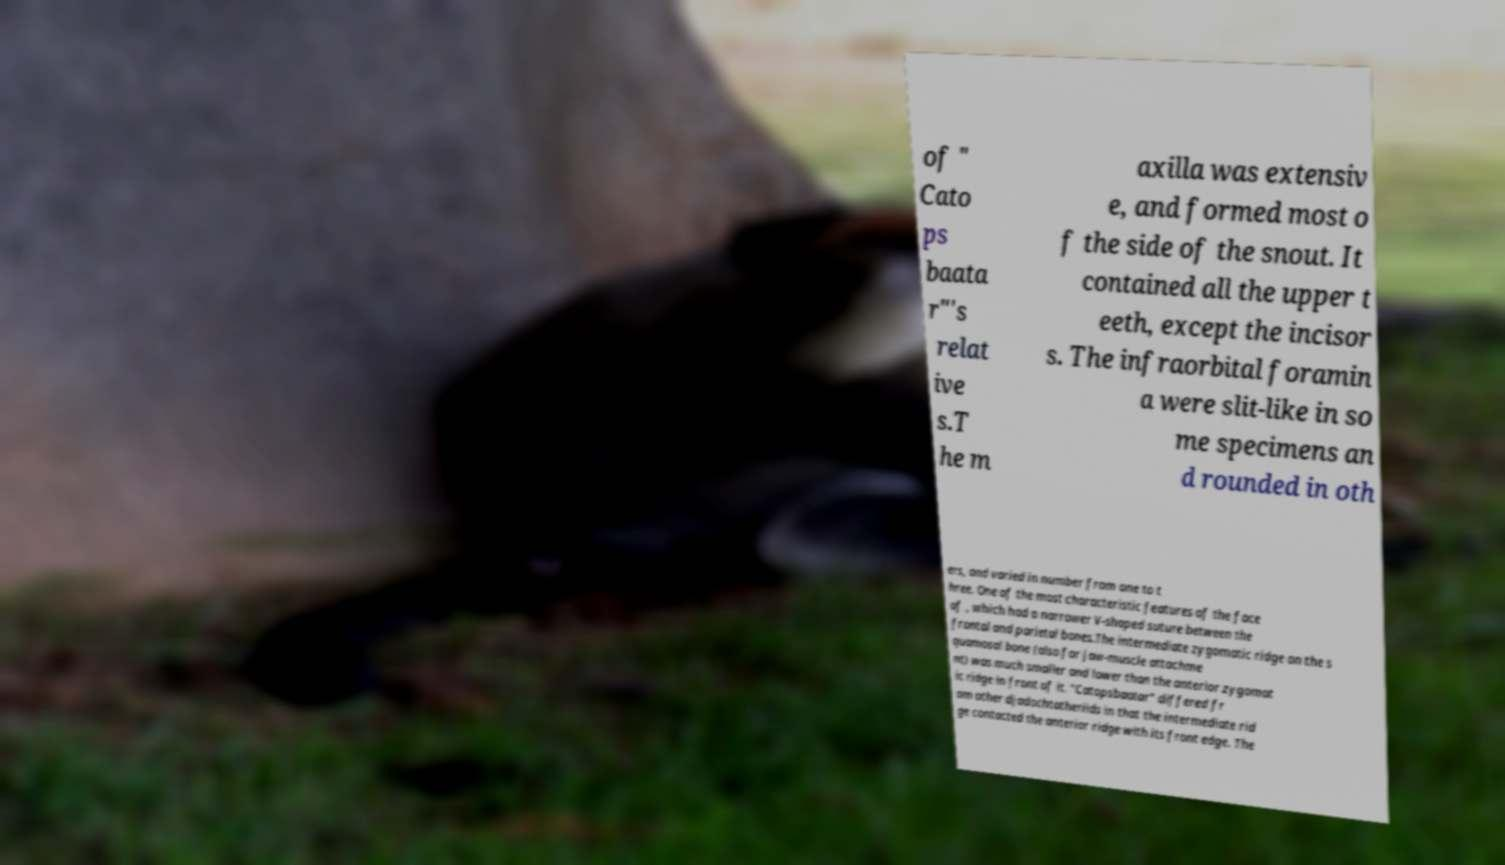For documentation purposes, I need the text within this image transcribed. Could you provide that? of " Cato ps baata r"'s relat ive s.T he m axilla was extensiv e, and formed most o f the side of the snout. It contained all the upper t eeth, except the incisor s. The infraorbital foramin a were slit-like in so me specimens an d rounded in oth ers, and varied in number from one to t hree. One of the most characteristic features of the face of , which had a narrower V-shaped suture between the frontal and parietal bones.The intermediate zygomatic ridge on the s quamosal bone (also for jaw-muscle attachme nt) was much smaller and lower than the anterior zygomat ic ridge in front of it. "Catopsbaatar" differed fr om other djadochtatheriids in that the intermediate rid ge contacted the anterior ridge with its front edge. The 